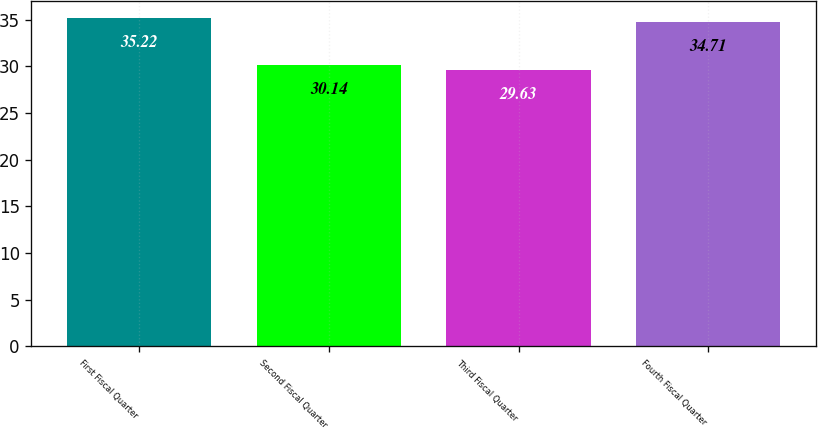Convert chart to OTSL. <chart><loc_0><loc_0><loc_500><loc_500><bar_chart><fcel>First Fiscal Quarter<fcel>Second Fiscal Quarter<fcel>Third Fiscal Quarter<fcel>Fourth Fiscal Quarter<nl><fcel>35.22<fcel>30.14<fcel>29.63<fcel>34.71<nl></chart> 